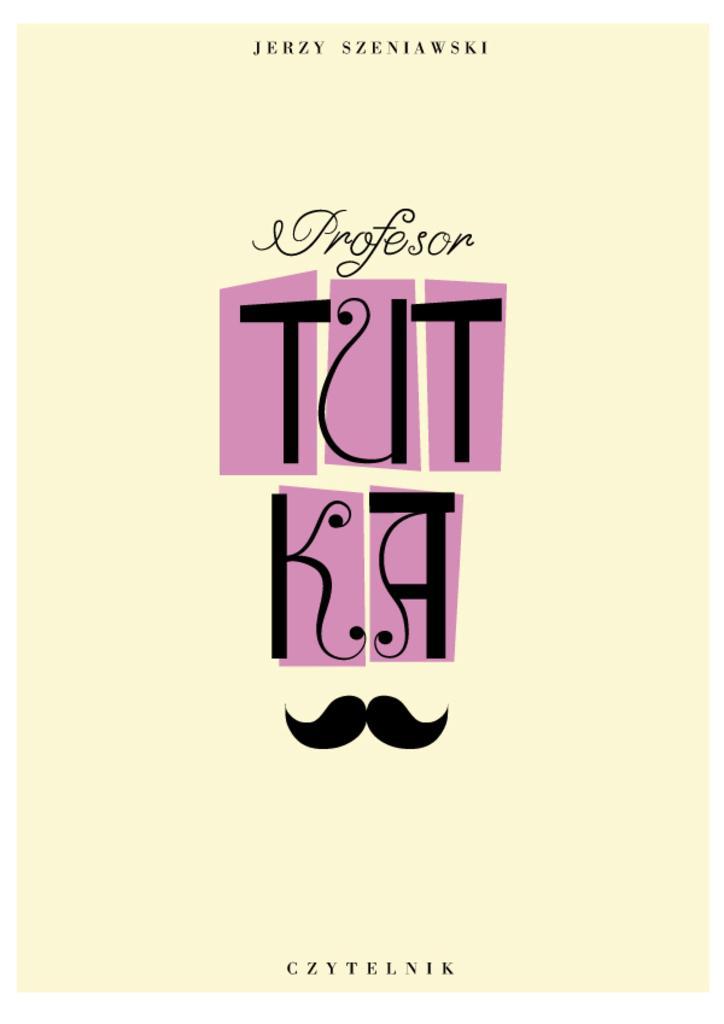Could you give a brief overview of what you see in this image? In this image we can see a poster with some text on it. 